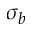<formula> <loc_0><loc_0><loc_500><loc_500>\sigma _ { b }</formula> 